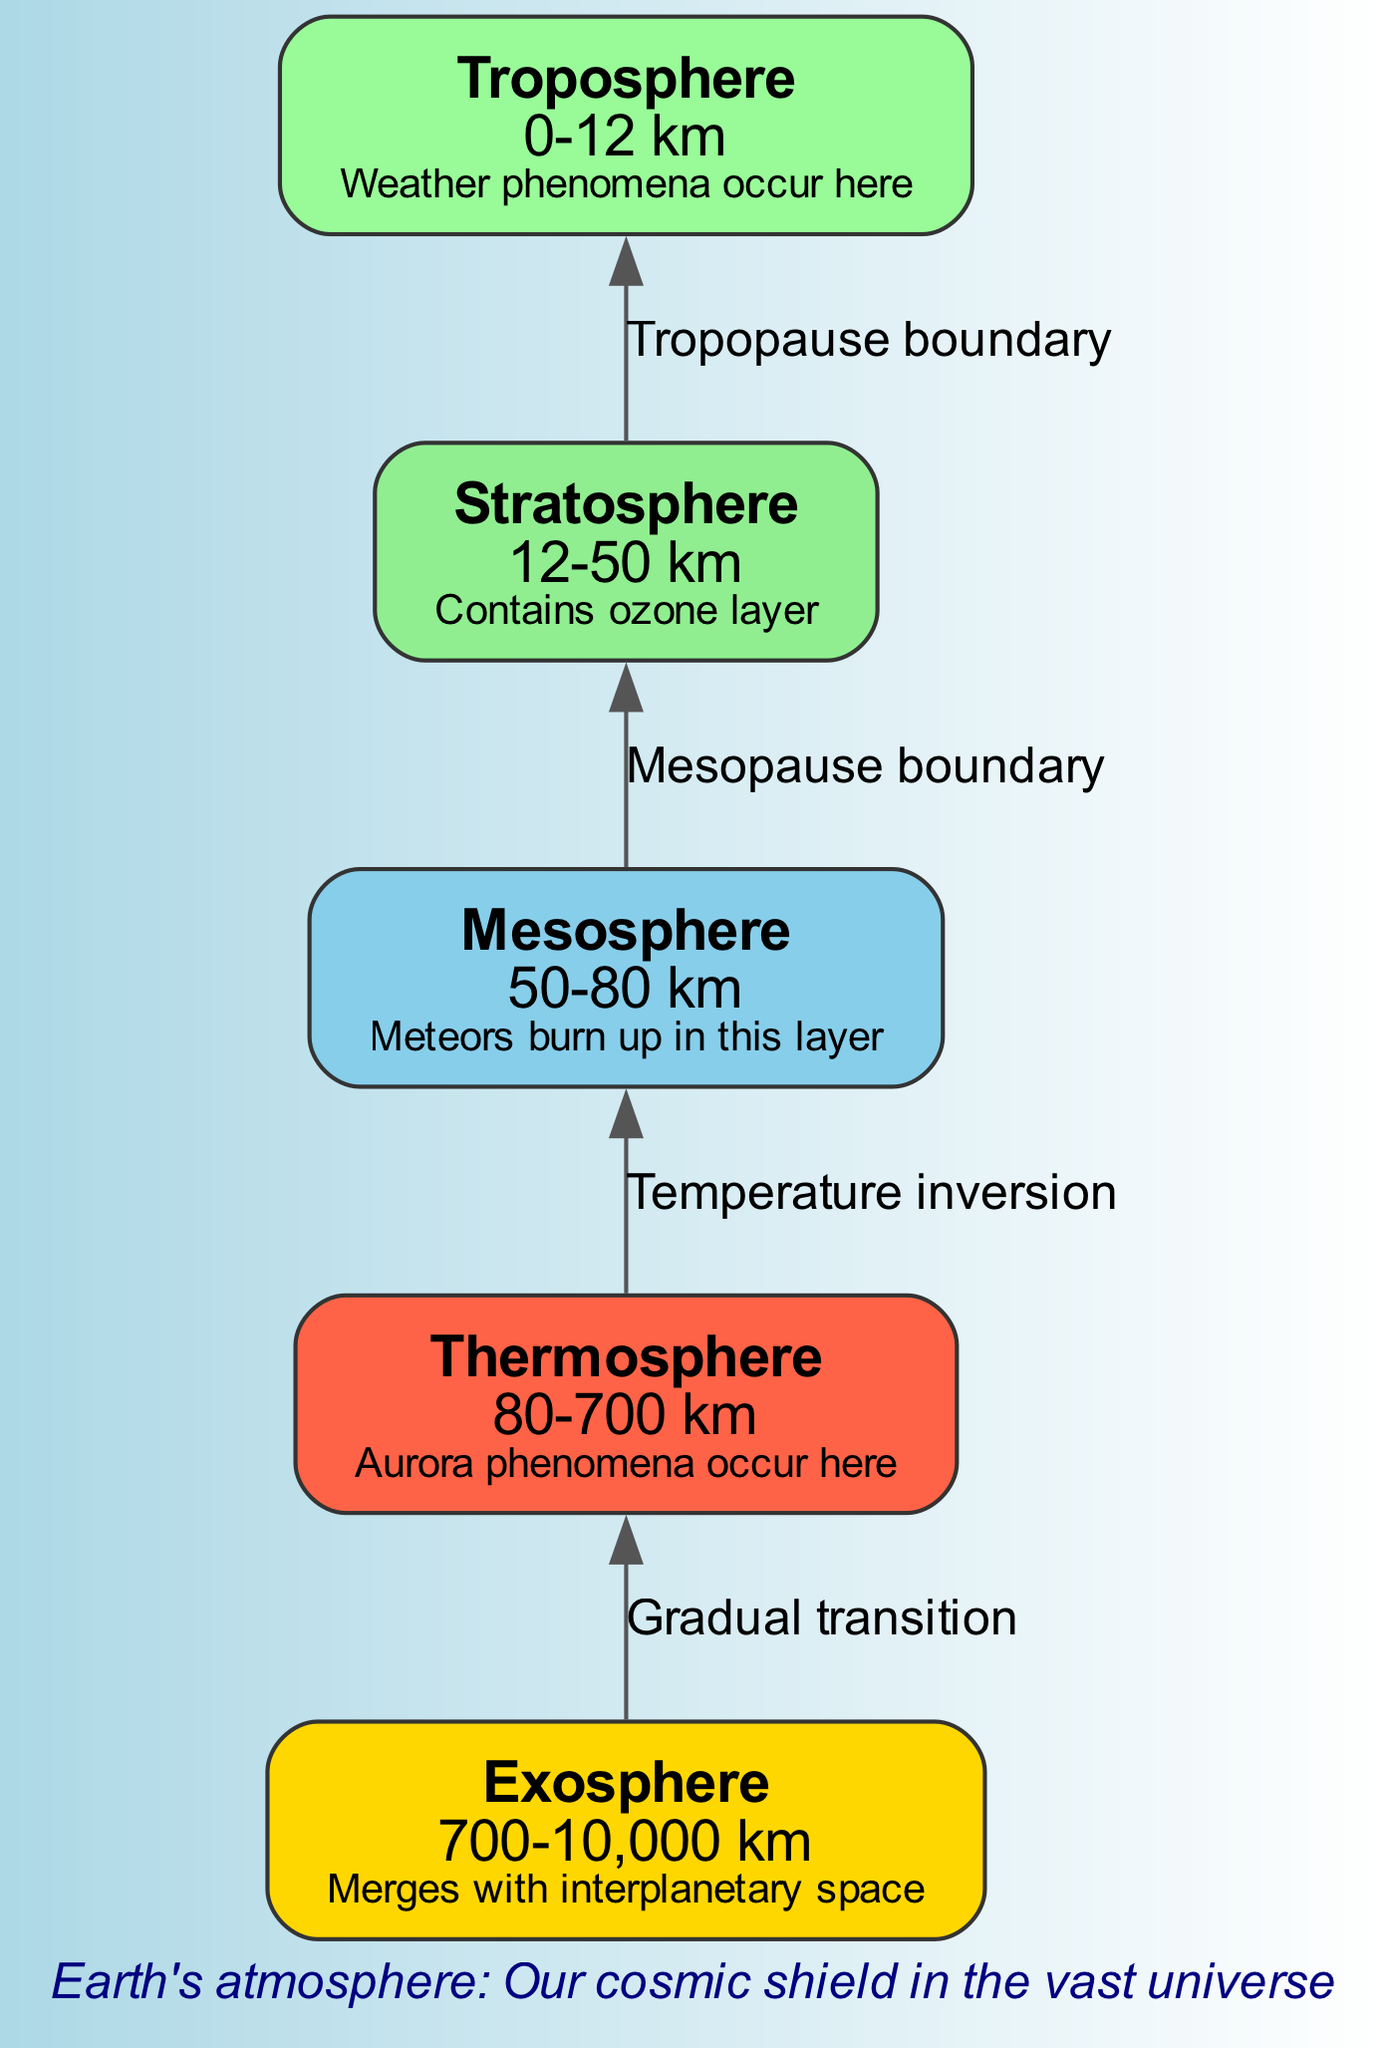What is the altitude range of the Stratosphere? The diagram clearly indicates that the Stratosphere has an altitude range from 12 to 50 km as provided in the layered information.
Answer: 12-50 km Which layer is known for meteor burn-up? The Mesosphere is listed in the diagram as the layer where meteors burn up, according to the specific feature associated with that layer.
Answer: Mesosphere What boundary separates the Stratosphere and Troposphere? The diagram specifies that the boundary between the Stratosphere and Troposphere is called the Tropopause boundary, which is explicitly labeled in the connections section.
Answer: Tropopause boundary What are the altitudes of the Exosphere? The Exosphere layer has an altitude range of 700 to 10,000 km stated in the information for that layer in the diagram.
Answer: 700-10,000 km Which layer features aurora phenomena? According to the diagram, the Thermosphere is highlighted for experiencing aurora phenomena, as indicated in the specific feature of that layer.
Answer: Thermosphere What is the relationship between the Thermosphere and Mesosphere? The diagram indicates a temperature inversion relationship between the Thermosphere and Mesosphere through the labeled connection. This means the temperature behavior exhibits an opposite trend compared to the layers above and below.
Answer: Temperature inversion How many distinct layers are listed in the diagram? The diagram lists a total of five distinct atmospheric layers: Exosphere, Thermosphere, Mesosphere, Stratosphere, and Troposphere. By counting each layer, we arrive at the total.
Answer: 5 From which layer does weather phenomena occur? The diagram specifies that weather phenomena occur in the Troposphere, as stated in that layer’s feature description.
Answer: Troposphere What is the feature of the Stratosphere? The diagram specifies that the Stratosphere contains the ozone layer as its key feature, directly denoting what sets it apart from other layers.
Answer: Contains ozone layer 